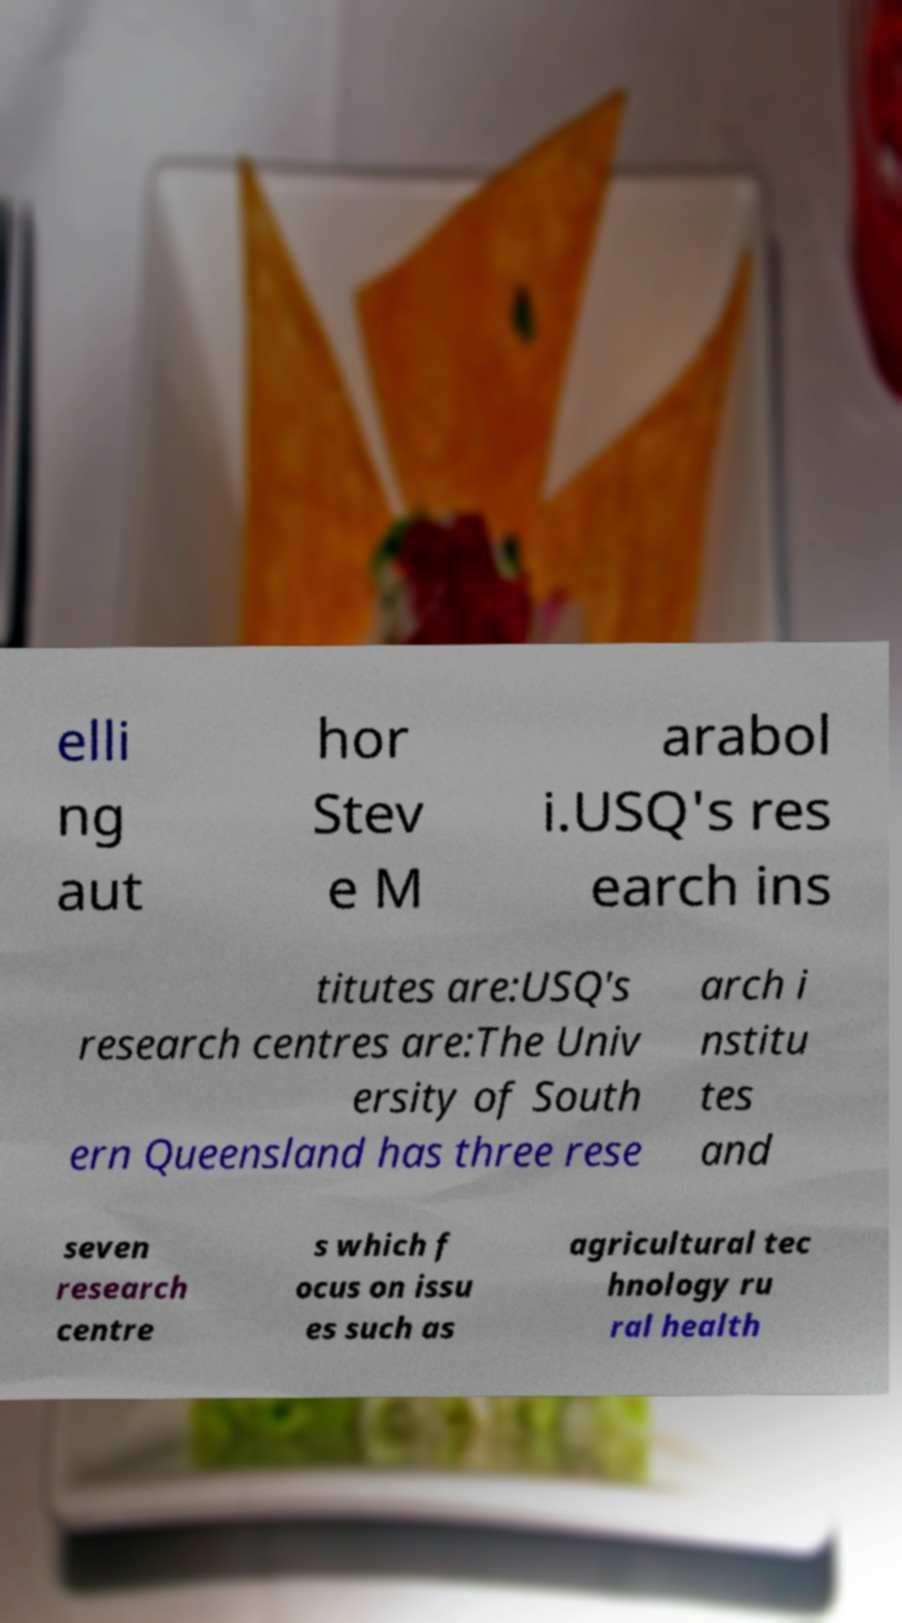Could you extract and type out the text from this image? elli ng aut hor Stev e M arabol i.USQ's res earch ins titutes are:USQ's research centres are:The Univ ersity of South ern Queensland has three rese arch i nstitu tes and seven research centre s which f ocus on issu es such as agricultural tec hnology ru ral health 